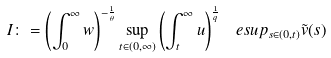<formula> <loc_0><loc_0><loc_500><loc_500>I \colon = \left ( \int _ { 0 } ^ { \infty } w \right ) ^ { - \frac { 1 } { \theta } } \sup _ { t \in ( 0 , \infty ) } \left ( \int _ { t } ^ { \infty } u \right ) ^ { \frac { 1 } { q } } \ e s u p _ { s \in ( 0 , t ) } \tilde { v } ( s )</formula> 